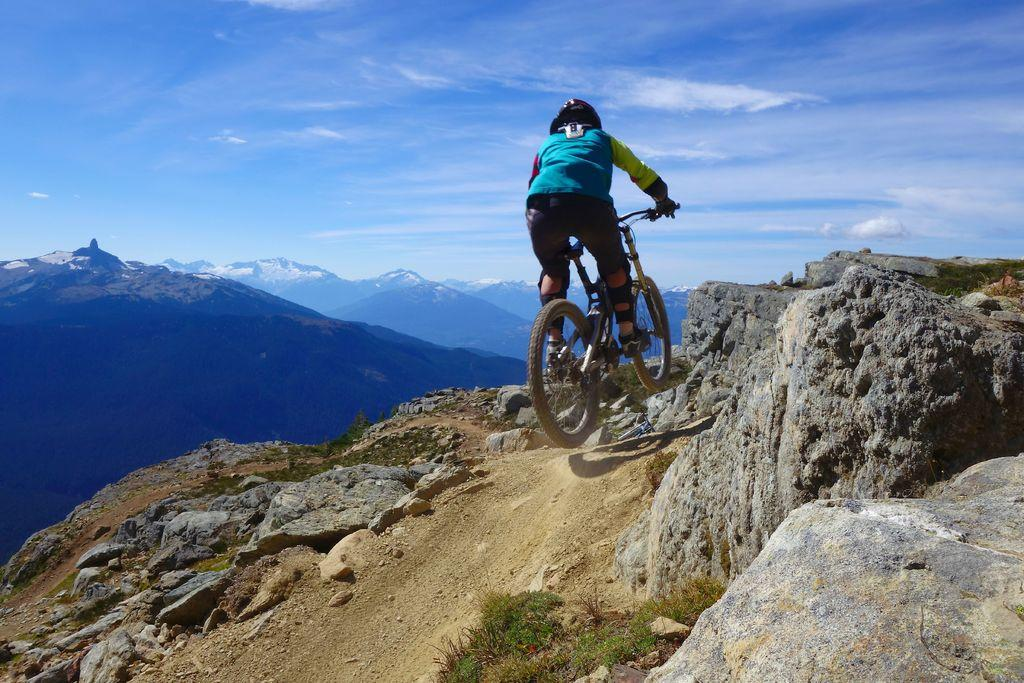What is the person in the image doing? There is a person cycling in the image. What is the terrain like where the person is cycling? The person is cycling on a hill. What can be seen on the right side of the image? There are stones on the right side of the image. What type of natural features can be seen in the background of the image? Hills, mountains, and the sky are visible in the background of the image. What is the condition of the sky in the image? Clouds are present in the sky in the image. What type of poisonous plant can be seen growing near the person cycling in the image? There is no poisonous plant visible in the image; the only objects mentioned are stones on the right side of the image. How many roses are present in the image? There are no roses visible in the image. 